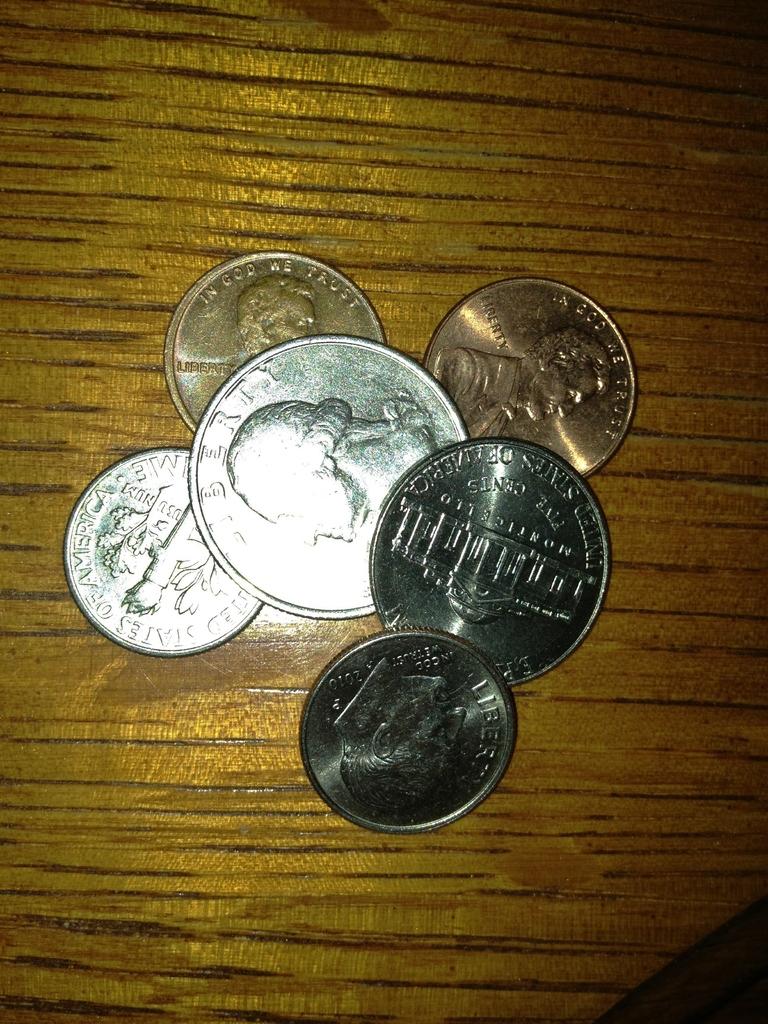"in god we" what?
Your answer should be compact. Trust. Where were the coins made?
Provide a short and direct response. Usa. 